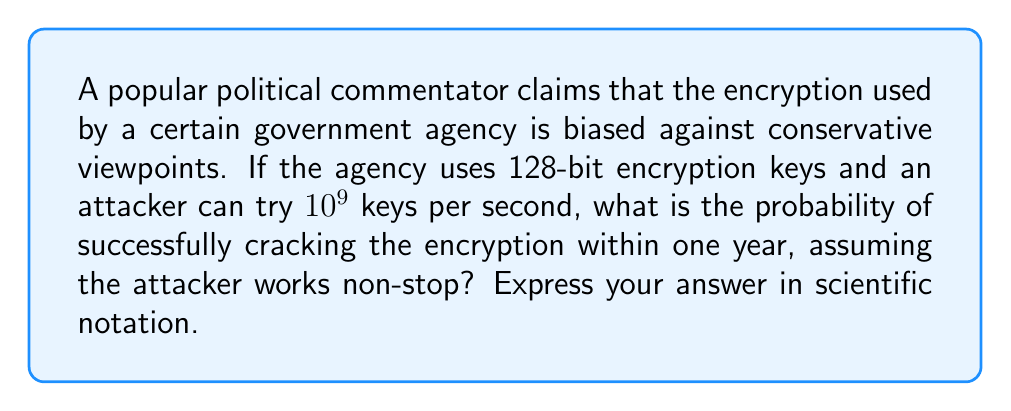Solve this math problem. Let's approach this step-by-step:

1) First, calculate the total number of possible 128-bit keys:
   $$2^{128} = 3.4028 \times 10^{38}$$ keys

2) Calculate how many keys can be tried in one year:
   $$10^9 \text{ keys/second} \times 60 \text{ seconds/minute} \times 60 \text{ minutes/hour} \times 24 \text{ hours/day} \times 365 \text{ days/year}$$
   $$= 3.1536 \times 10^{16} \text{ keys/year}$$

3) The probability of success is the number of keys that can be tried divided by the total number of possible keys:
   $$P(\text{success}) = \frac{3.1536 \times 10^{16}}{3.4028 \times 10^{38}}$$

4) Simplify:
   $$P(\text{success}) = 9.2676 \times 10^{-23}$$

This extremely low probability suggests that the encryption is highly secure and unbiased, regardless of political viewpoints.
Answer: $9.2676 \times 10^{-23}$ 